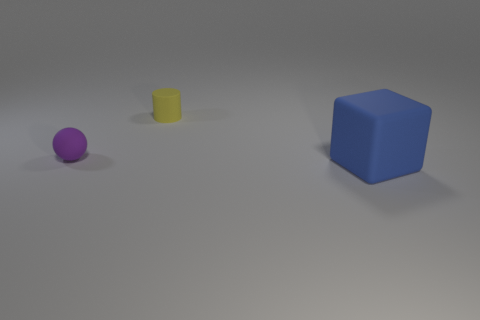Add 1 small purple spheres. How many objects exist? 4 Subtract all cylinders. How many objects are left? 2 Subtract all tiny gray balls. Subtract all yellow cylinders. How many objects are left? 2 Add 2 yellow cylinders. How many yellow cylinders are left? 3 Add 1 purple balls. How many purple balls exist? 2 Subtract 0 blue spheres. How many objects are left? 3 